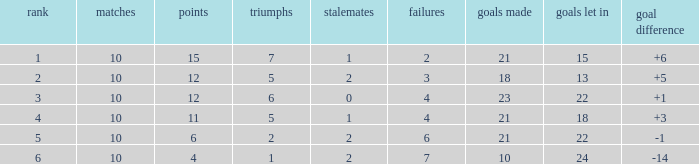Can you tell me the lowest Played that has the Position larger than 2, and the Draws smaller than 2, and the Goals against smaller than 18? None. 